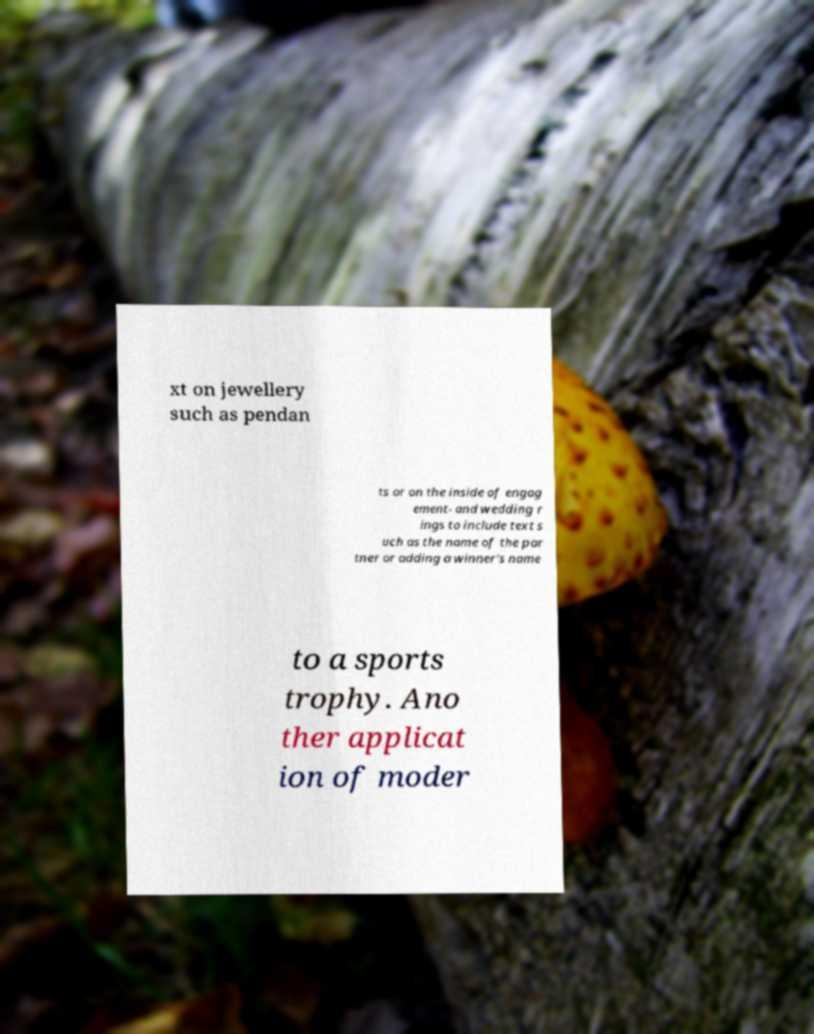Can you read and provide the text displayed in the image?This photo seems to have some interesting text. Can you extract and type it out for me? xt on jewellery such as pendan ts or on the inside of engag ement- and wedding r ings to include text s uch as the name of the par tner or adding a winner's name to a sports trophy. Ano ther applicat ion of moder 